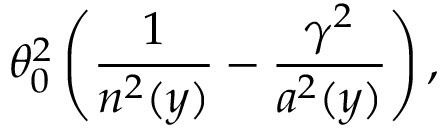Convert formula to latex. <formula><loc_0><loc_0><loc_500><loc_500>\theta _ { 0 } ^ { 2 } \left ( \frac { 1 } { n ^ { 2 } ( y ) } - \frac { \gamma ^ { 2 } } { a ^ { 2 } ( y ) } \right ) ,</formula> 